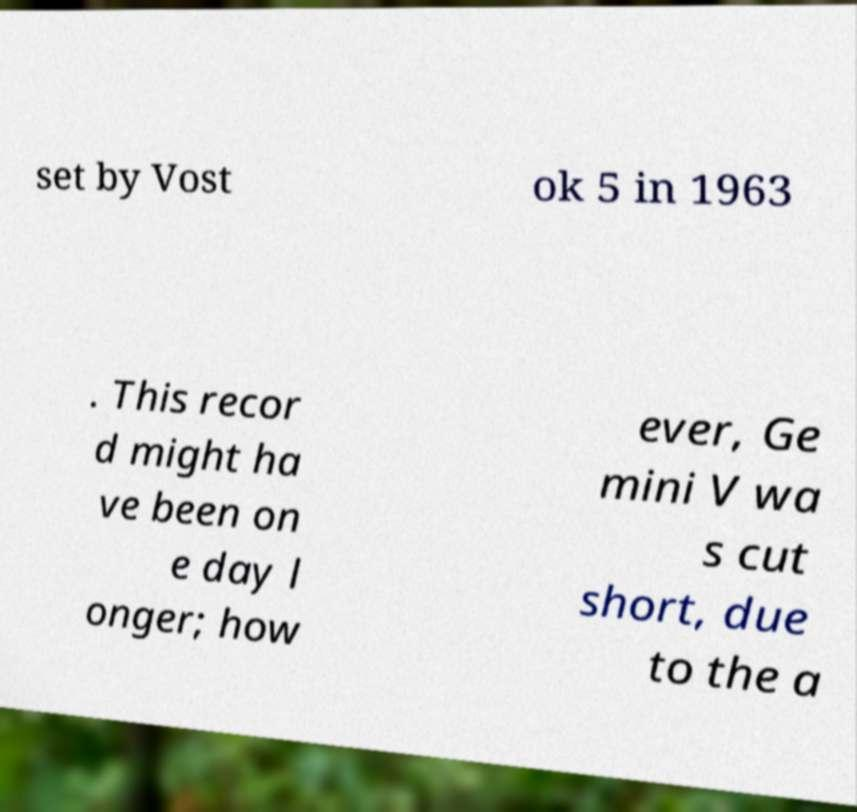Please identify and transcribe the text found in this image. set by Vost ok 5 in 1963 . This recor d might ha ve been on e day l onger; how ever, Ge mini V wa s cut short, due to the a 